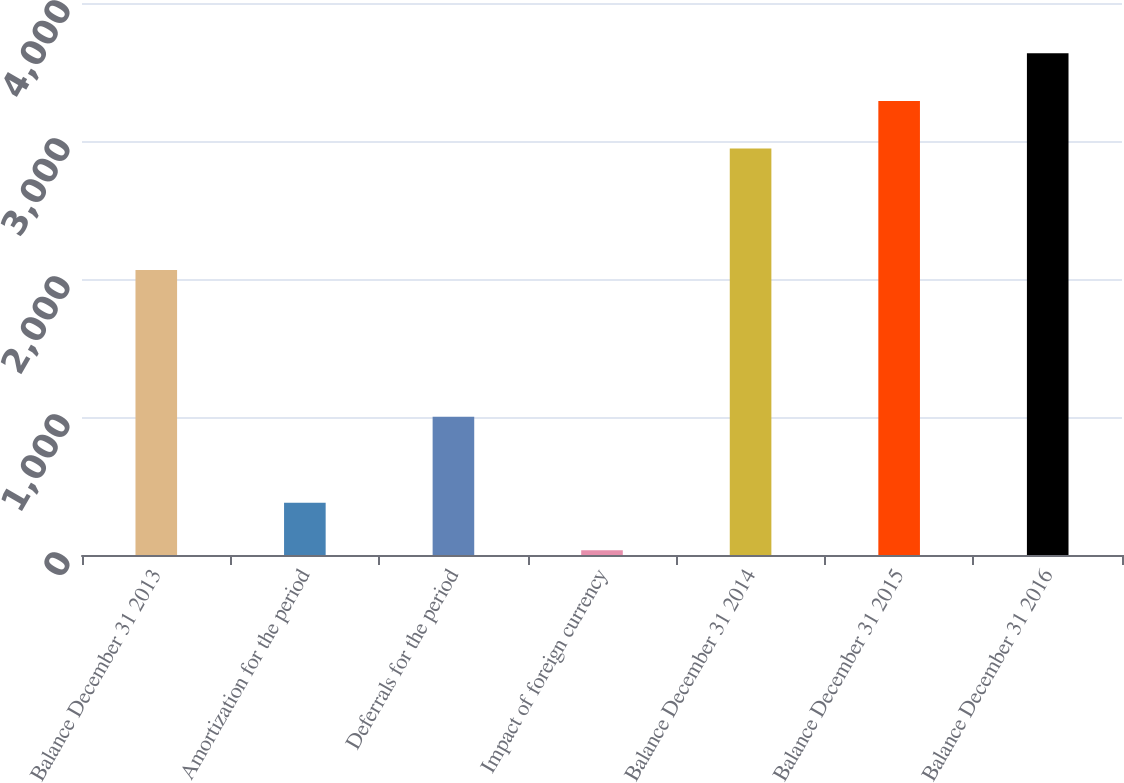<chart> <loc_0><loc_0><loc_500><loc_500><bar_chart><fcel>Balance December 31 2013<fcel>Amortization for the period<fcel>Deferrals for the period<fcel>Impact of foreign currency<fcel>Balance December 31 2014<fcel>Balance December 31 2015<fcel>Balance December 31 2016<nl><fcel>2065<fcel>378.7<fcel>1001<fcel>34<fcel>2946<fcel>3290.7<fcel>3635.4<nl></chart> 